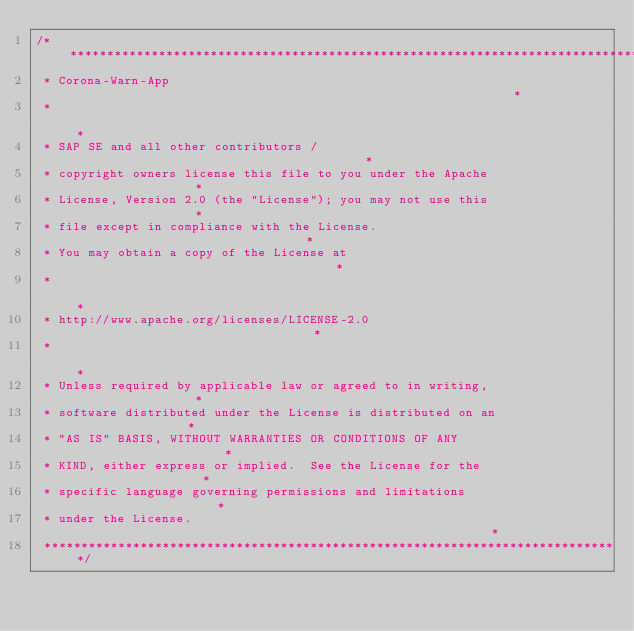Convert code to text. <code><loc_0><loc_0><loc_500><loc_500><_Kotlin_>/******************************************************************************
 * Corona-Warn-App                                                            *
 *                                                                            *
 * SAP SE and all other contributors /                                        *
 * copyright owners license this file to you under the Apache                 *
 * License, Version 2.0 (the "License"); you may not use this                 *
 * file except in compliance with the License.                                *
 * You may obtain a copy of the License at                                    *
 *                                                                            *
 * http://www.apache.org/licenses/LICENSE-2.0                                 *
 *                                                                            *
 * Unless required by applicable law or agreed to in writing,                 *
 * software distributed under the License is distributed on an                *
 * "AS IS" BASIS, WITHOUT WARRANTIES OR CONDITIONS OF ANY                     *
 * KIND, either express or implied.  See the License for the                  *
 * specific language governing permissions and limitations                    *
 * under the License.                                                         *
 ******************************************************************************/
</code> 